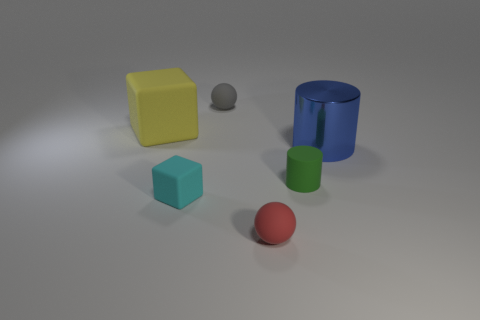What is the shape of the tiny red matte object?
Your answer should be very brief. Sphere. What material is the object that is behind the green object and right of the tiny gray matte sphere?
Keep it short and to the point. Metal. What is the shape of the gray object that is the same material as the green thing?
Make the answer very short. Sphere. The cyan thing that is the same material as the green cylinder is what size?
Keep it short and to the point. Small. The thing that is both behind the small green thing and in front of the yellow block has what shape?
Provide a short and direct response. Cylinder. What size is the matte sphere in front of the sphere that is on the left side of the red matte ball?
Offer a very short reply. Small. What material is the large blue thing?
Offer a very short reply. Metal. Are there any large blue cylinders?
Ensure brevity in your answer.  Yes. Is the number of yellow things right of the tiny cyan object the same as the number of big shiny things?
Offer a very short reply. No. Are there any other things that are the same material as the blue object?
Your response must be concise. No. 